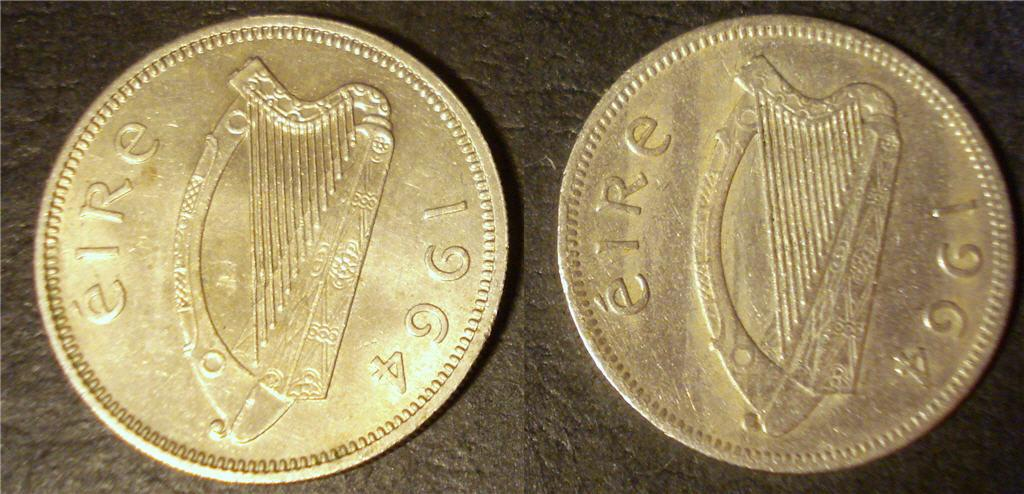<image>
Describe the image concisely. Two gold coins lying side by side that say elRe 1964 on the coins. 